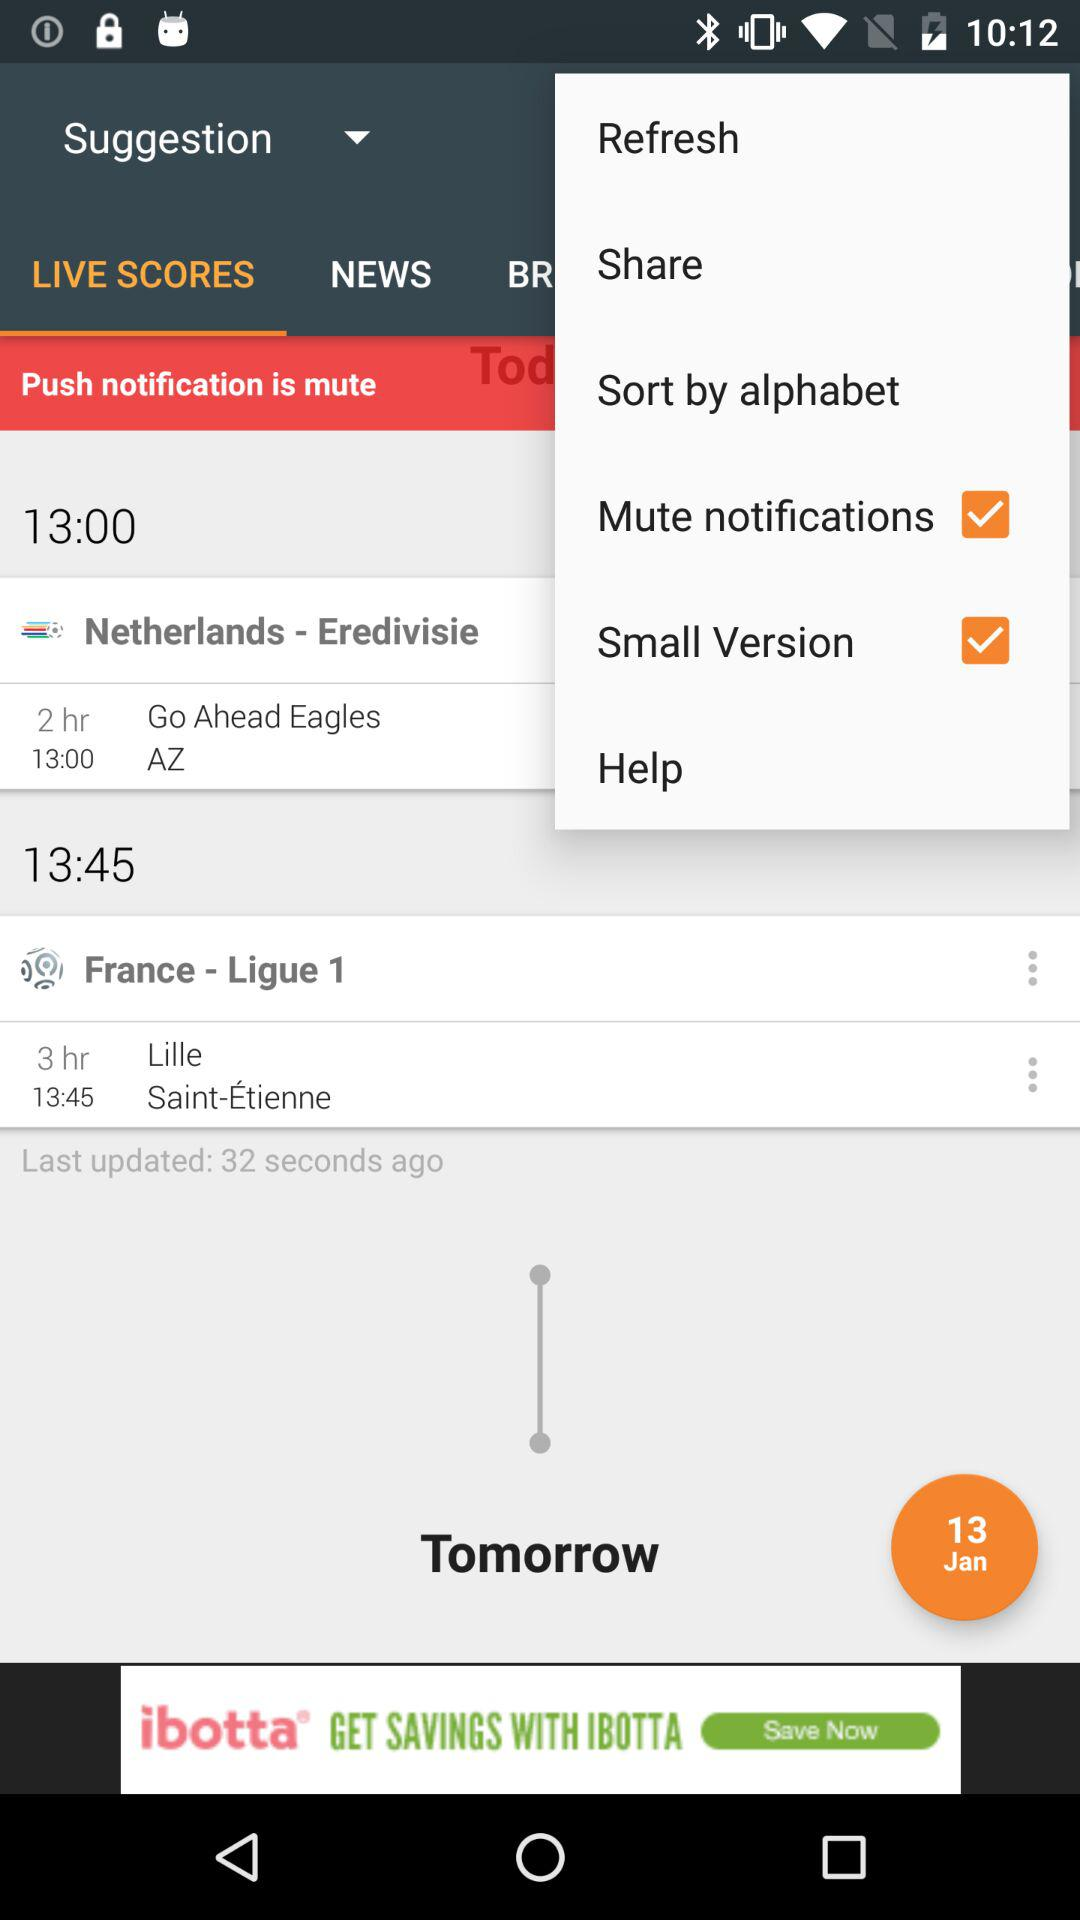What is the match time for "France - Ligue 1"? The match time for "France - Ligue 1" is 13:45. 